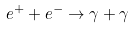Convert formula to latex. <formula><loc_0><loc_0><loc_500><loc_500>e ^ { + } + e ^ { - } \rightarrow \gamma + \gamma</formula> 